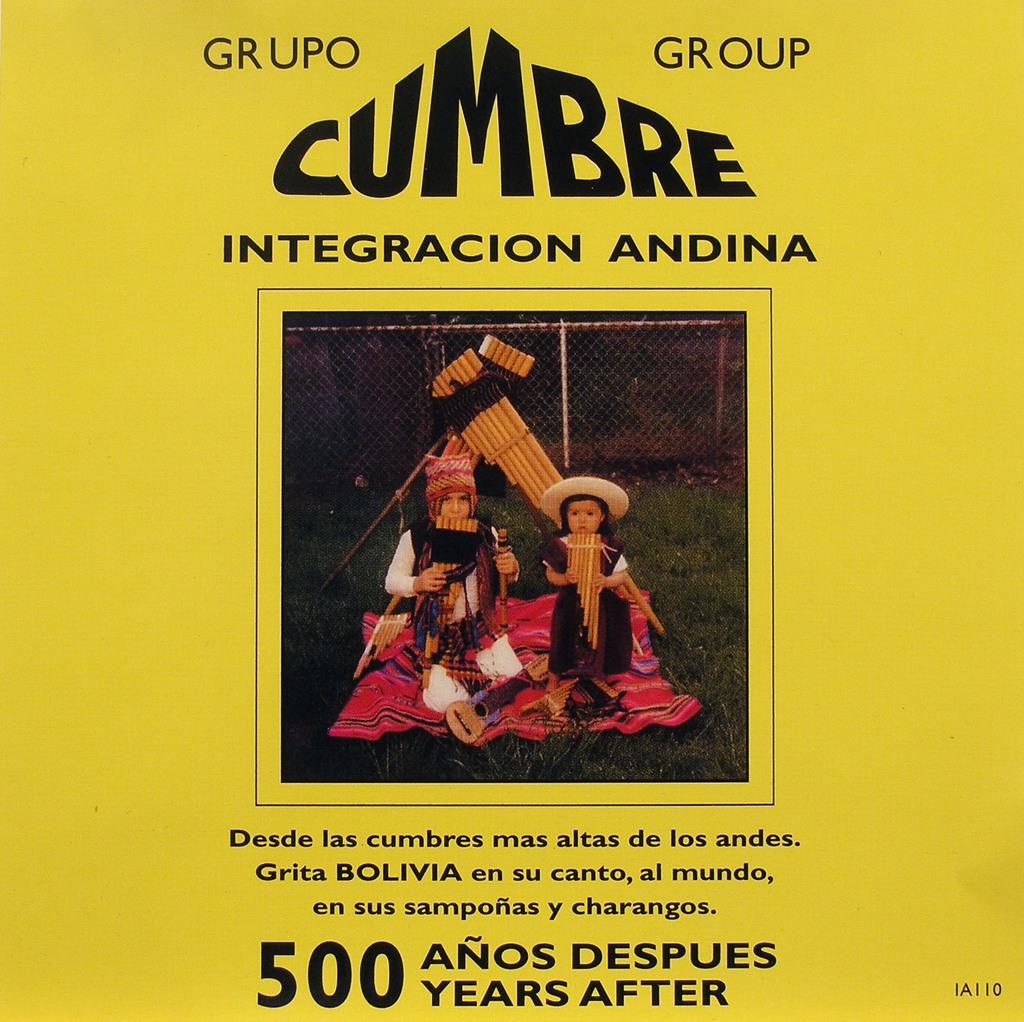What type of visual medium is the image? The image appears to be a poster. What is depicted in the main image on the poster? There is a picture of two people with fancy dresses on the poster. What else is featured on the poster besides the main image? There are letters on the poster. What color is the background of the poster? The background of the poster looks yellow in color. What type of home can be seen in the background of the poster? There is no home visible in the background of the poster; it only features the two people in fancy dresses and the yellow background. What activity are the two people engaged in on the poster? The image does not show the two people in any specific activity; they are simply depicted wearing fancy dresses. 